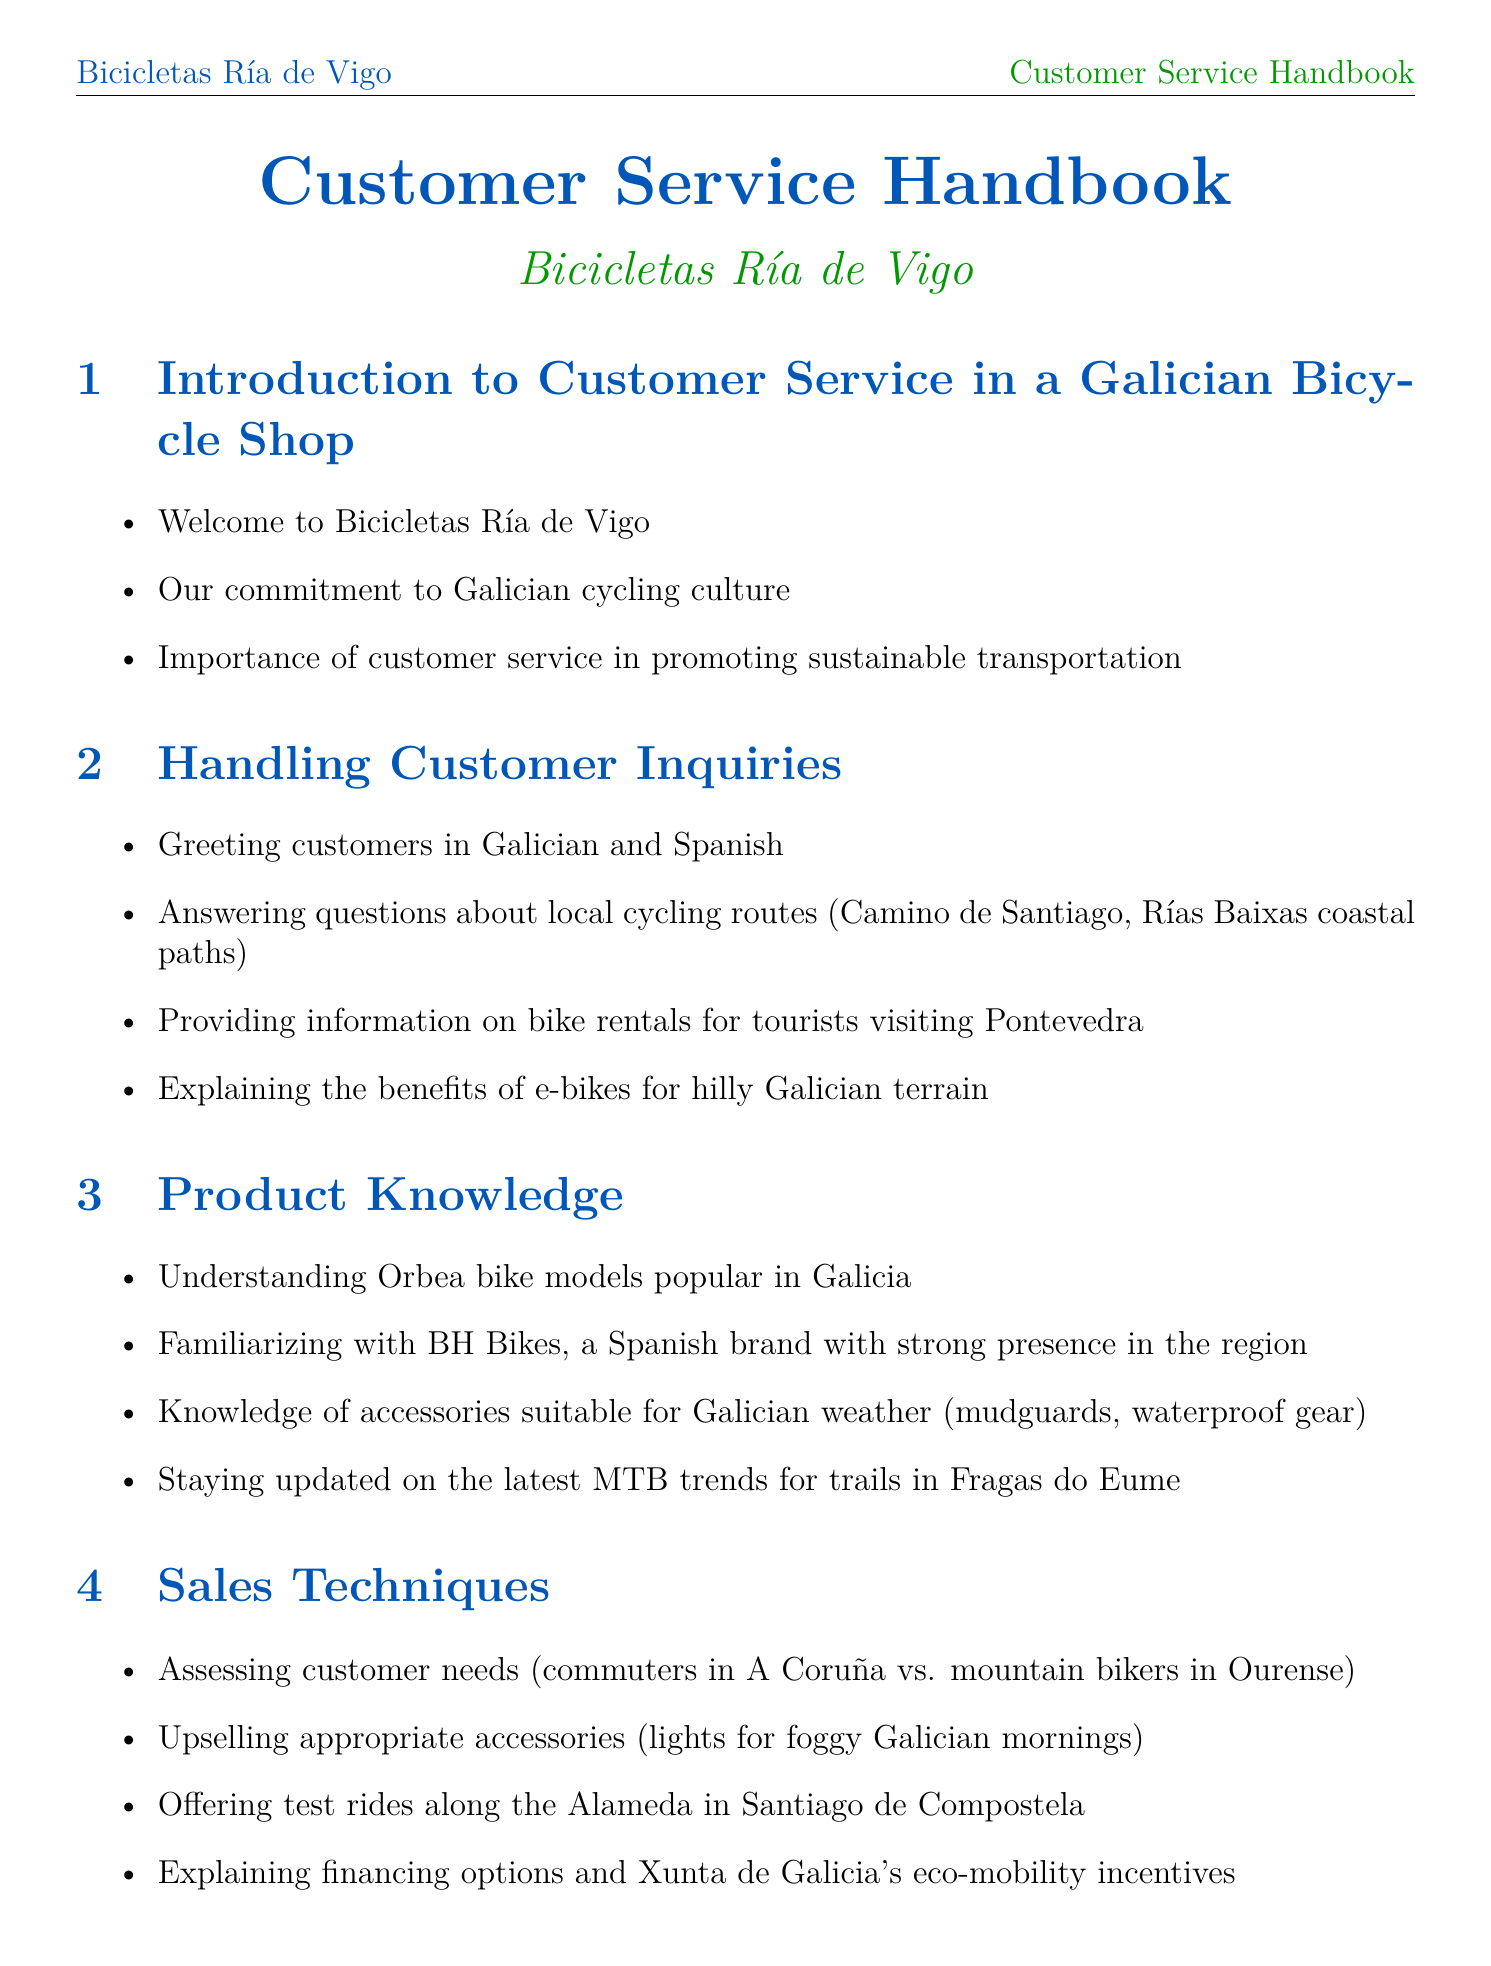What is the title of the manual? The title is prominently displayed at the beginning of the document.
Answer: Customer Service Handbook What local cycling route is mentioned? The document lists specific routes in the section about handling inquiries.
Answer: Camino de Santiago Which Spanish brand of bikes is familiarized in the document? This information is found in the product knowledge section.
Answer: BH Bikes What is one reason for the importance of customer service? This reason can be found in the introduction section.
Answer: Promoting sustainable transportation What should be done before the Volta a Galicia event? This maintenance activity is listed in the after-sales support section.
Answer: Scheduling maintenance check-ups What kind of community engagement activity is mentioned? This is described in the local community engagement section.
Answer: Organizing group rides What language should tutorials be provided in? This information is located in the after-sales support section.
Answer: Galician language How often should staff training occur? The section on continuous improvement discusses staff training frequency.
Answer: Regularly What is an accessory that can be upsold? This accessory is mentioned in the sales techniques section.
Answer: Lights for foggy Galician mornings 